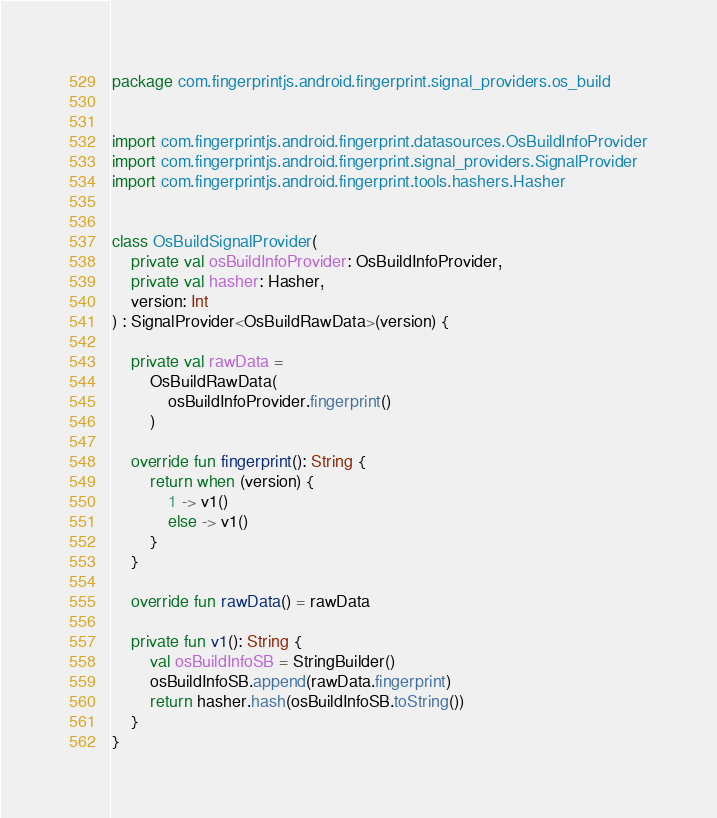<code> <loc_0><loc_0><loc_500><loc_500><_Kotlin_>package com.fingerprintjs.android.fingerprint.signal_providers.os_build


import com.fingerprintjs.android.fingerprint.datasources.OsBuildInfoProvider
import com.fingerprintjs.android.fingerprint.signal_providers.SignalProvider
import com.fingerprintjs.android.fingerprint.tools.hashers.Hasher


class OsBuildSignalProvider(
    private val osBuildInfoProvider: OsBuildInfoProvider,
    private val hasher: Hasher,
    version: Int
) : SignalProvider<OsBuildRawData>(version) {

    private val rawData =
        OsBuildRawData(
            osBuildInfoProvider.fingerprint()
        )

    override fun fingerprint(): String {
        return when (version) {
            1 -> v1()
            else -> v1()
        }
    }

    override fun rawData() = rawData

    private fun v1(): String {
        val osBuildInfoSB = StringBuilder()
        osBuildInfoSB.append(rawData.fingerprint)
        return hasher.hash(osBuildInfoSB.toString())
    }
}</code> 